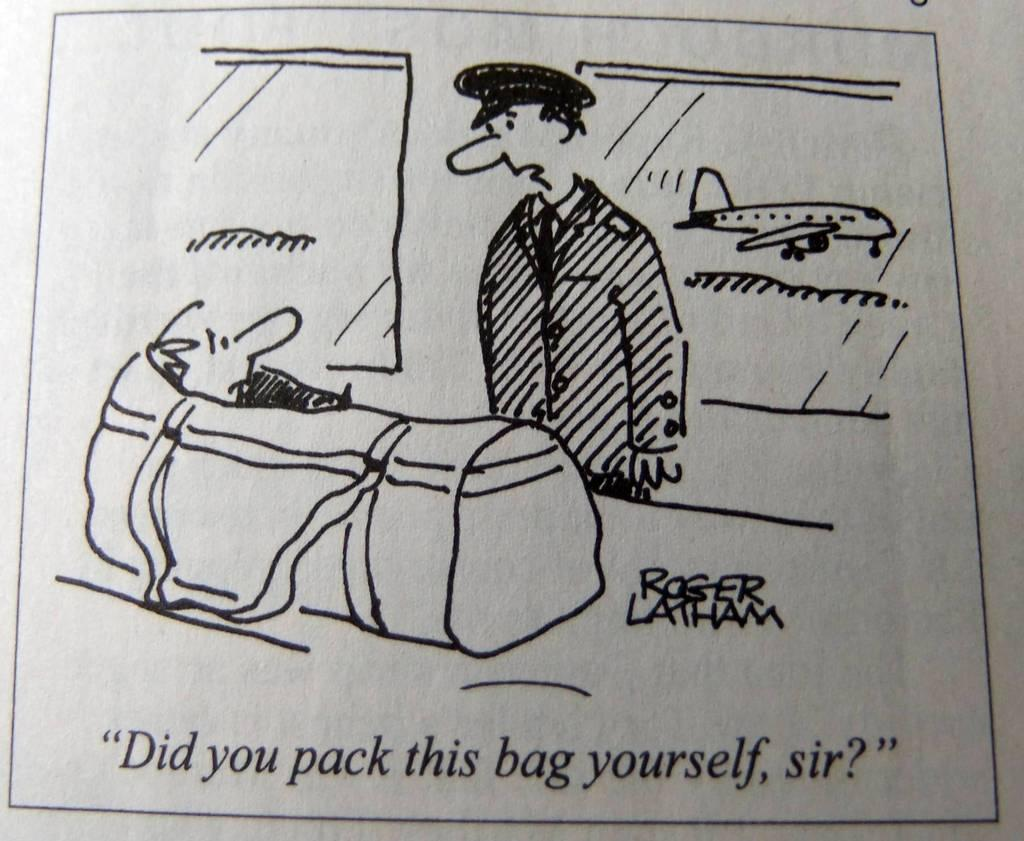What is the main subject of the sketch? The sketch contains an image of a man. What other objects or figures are present in the sketch? The sketch contains an image of a bag, a child, and an airplane. What type of sign can be seen in the wilderness in the sketch? There is no sign present in the sketch, nor is there any wilderness depicted. 